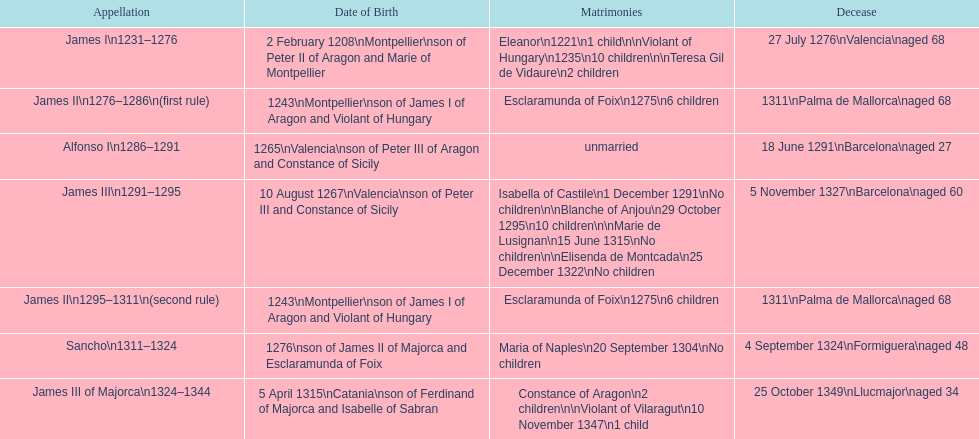Which two monarchs had no children? Alfonso I, Sancho. 